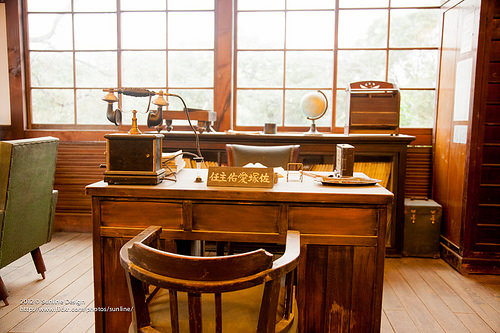<image>
Can you confirm if the window is under the window? No. The window is not positioned under the window. The vertical relationship between these objects is different. Is the globe behind the chair? Yes. From this viewpoint, the globe is positioned behind the chair, with the chair partially or fully occluding the globe. Where is the name plate in relation to the chair? Is it above the chair? No. The name plate is not positioned above the chair. The vertical arrangement shows a different relationship. 